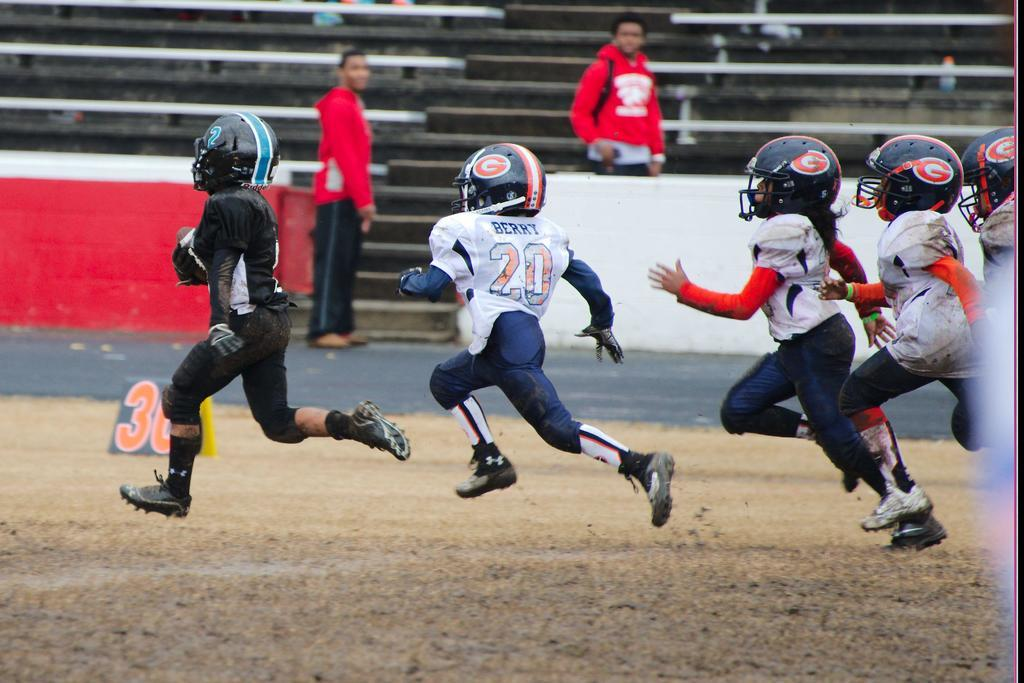What are the persons in the image doing? The persons in the image are running on the ground. What can be seen in the background of the image? In the background of the image, there are stairs, additional persons, and benches. What type of star can be seen shining in the image? There is no star visible in the image; it is focused on persons running and the background elements. 